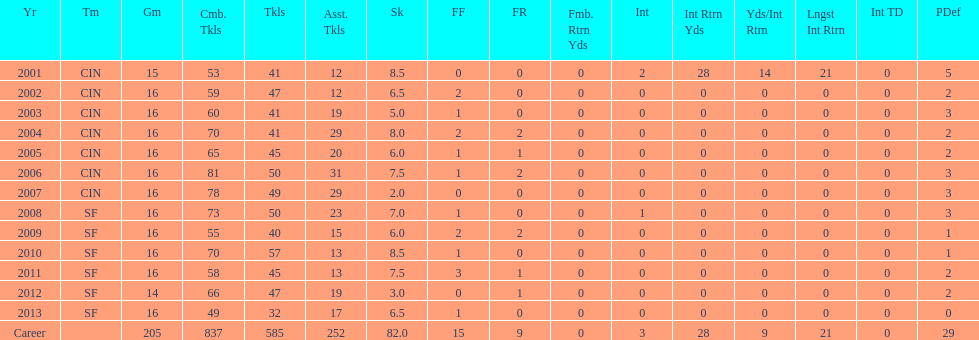How many consecutive seasons has he played sixteen games? 10. 